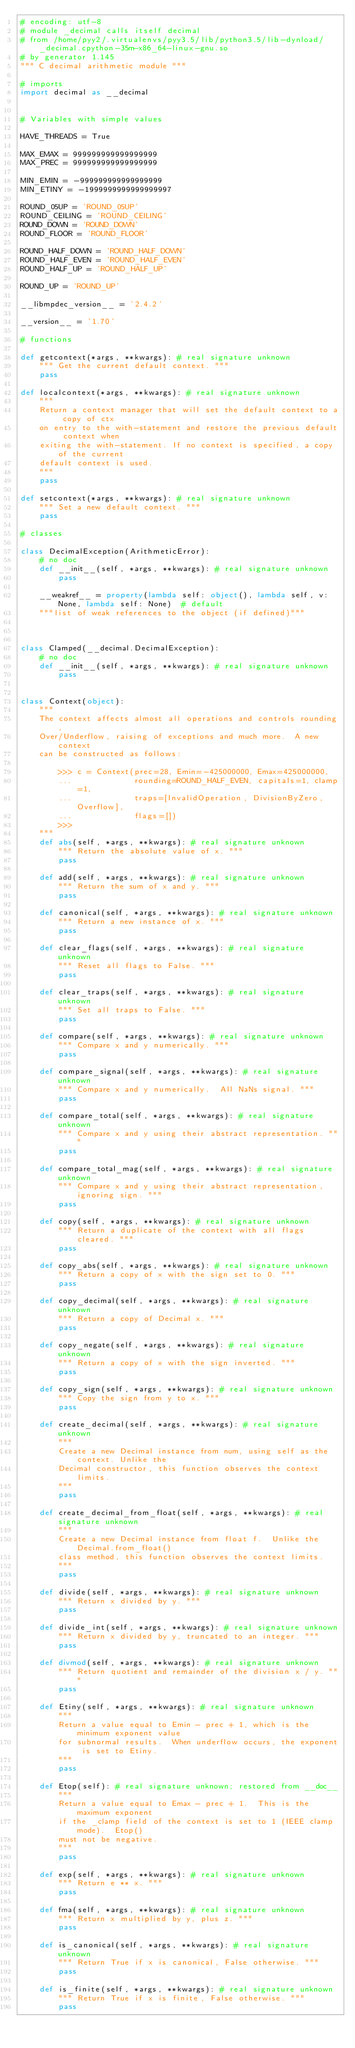<code> <loc_0><loc_0><loc_500><loc_500><_Python_># encoding: utf-8
# module _decimal calls itself decimal
# from /home/pyy2/.virtualenvs/pyy3.5/lib/python3.5/lib-dynload/_decimal.cpython-35m-x86_64-linux-gnu.so
# by generator 1.145
""" C decimal arithmetic module """

# imports
import decimal as __decimal


# Variables with simple values

HAVE_THREADS = True

MAX_EMAX = 999999999999999999
MAX_PREC = 999999999999999999

MIN_EMIN = -999999999999999999
MIN_ETINY = -1999999999999999997

ROUND_05UP = 'ROUND_05UP'
ROUND_CEILING = 'ROUND_CEILING'
ROUND_DOWN = 'ROUND_DOWN'
ROUND_FLOOR = 'ROUND_FLOOR'

ROUND_HALF_DOWN = 'ROUND_HALF_DOWN'
ROUND_HALF_EVEN = 'ROUND_HALF_EVEN'
ROUND_HALF_UP = 'ROUND_HALF_UP'

ROUND_UP = 'ROUND_UP'

__libmpdec_version__ = '2.4.2'

__version__ = '1.70'

# functions

def getcontext(*args, **kwargs): # real signature unknown
    """ Get the current default context. """
    pass

def localcontext(*args, **kwargs): # real signature unknown
    """
    Return a context manager that will set the default context to a copy of ctx
    on entry to the with-statement and restore the previous default context when
    exiting the with-statement. If no context is specified, a copy of the current
    default context is used.
    """
    pass

def setcontext(*args, **kwargs): # real signature unknown
    """ Set a new default context. """
    pass

# classes

class DecimalException(ArithmeticError):
    # no doc
    def __init__(self, *args, **kwargs): # real signature unknown
        pass

    __weakref__ = property(lambda self: object(), lambda self, v: None, lambda self: None)  # default
    """list of weak references to the object (if defined)"""



class Clamped(__decimal.DecimalException):
    # no doc
    def __init__(self, *args, **kwargs): # real signature unknown
        pass


class Context(object):
    """
    The context affects almost all operations and controls rounding,
    Over/Underflow, raising of exceptions and much more.  A new context
    can be constructed as follows:
    
        >>> c = Context(prec=28, Emin=-425000000, Emax=425000000,
        ...             rounding=ROUND_HALF_EVEN, capitals=1, clamp=1,
        ...             traps=[InvalidOperation, DivisionByZero, Overflow],
        ...             flags=[])
        >>>
    """
    def abs(self, *args, **kwargs): # real signature unknown
        """ Return the absolute value of x. """
        pass

    def add(self, *args, **kwargs): # real signature unknown
        """ Return the sum of x and y. """
        pass

    def canonical(self, *args, **kwargs): # real signature unknown
        """ Return a new instance of x. """
        pass

    def clear_flags(self, *args, **kwargs): # real signature unknown
        """ Reset all flags to False. """
        pass

    def clear_traps(self, *args, **kwargs): # real signature unknown
        """ Set all traps to False. """
        pass

    def compare(self, *args, **kwargs): # real signature unknown
        """ Compare x and y numerically. """
        pass

    def compare_signal(self, *args, **kwargs): # real signature unknown
        """ Compare x and y numerically.  All NaNs signal. """
        pass

    def compare_total(self, *args, **kwargs): # real signature unknown
        """ Compare x and y using their abstract representation. """
        pass

    def compare_total_mag(self, *args, **kwargs): # real signature unknown
        """ Compare x and y using their abstract representation, ignoring sign. """
        pass

    def copy(self, *args, **kwargs): # real signature unknown
        """ Return a duplicate of the context with all flags cleared. """
        pass

    def copy_abs(self, *args, **kwargs): # real signature unknown
        """ Return a copy of x with the sign set to 0. """
        pass

    def copy_decimal(self, *args, **kwargs): # real signature unknown
        """ Return a copy of Decimal x. """
        pass

    def copy_negate(self, *args, **kwargs): # real signature unknown
        """ Return a copy of x with the sign inverted. """
        pass

    def copy_sign(self, *args, **kwargs): # real signature unknown
        """ Copy the sign from y to x. """
        pass

    def create_decimal(self, *args, **kwargs): # real signature unknown
        """
        Create a new Decimal instance from num, using self as the context. Unlike the
        Decimal constructor, this function observes the context limits.
        """
        pass

    def create_decimal_from_float(self, *args, **kwargs): # real signature unknown
        """
        Create a new Decimal instance from float f.  Unlike the Decimal.from_float()
        class method, this function observes the context limits.
        """
        pass

    def divide(self, *args, **kwargs): # real signature unknown
        """ Return x divided by y. """
        pass

    def divide_int(self, *args, **kwargs): # real signature unknown
        """ Return x divided by y, truncated to an integer. """
        pass

    def divmod(self, *args, **kwargs): # real signature unknown
        """ Return quotient and remainder of the division x / y. """
        pass

    def Etiny(self, *args, **kwargs): # real signature unknown
        """
        Return a value equal to Emin - prec + 1, which is the minimum exponent value
        for subnormal results.  When underflow occurs, the exponent is set to Etiny.
        """
        pass

    def Etop(self): # real signature unknown; restored from __doc__
        """
        Return a value equal to Emax - prec + 1.  This is the maximum exponent
        if the _clamp field of the context is set to 1 (IEEE clamp mode).  Etop()
        must not be negative.
        """
        pass

    def exp(self, *args, **kwargs): # real signature unknown
        """ Return e ** x. """
        pass

    def fma(self, *args, **kwargs): # real signature unknown
        """ Return x multiplied by y, plus z. """
        pass

    def is_canonical(self, *args, **kwargs): # real signature unknown
        """ Return True if x is canonical, False otherwise. """
        pass

    def is_finite(self, *args, **kwargs): # real signature unknown
        """ Return True if x is finite, False otherwise. """
        pass
</code> 